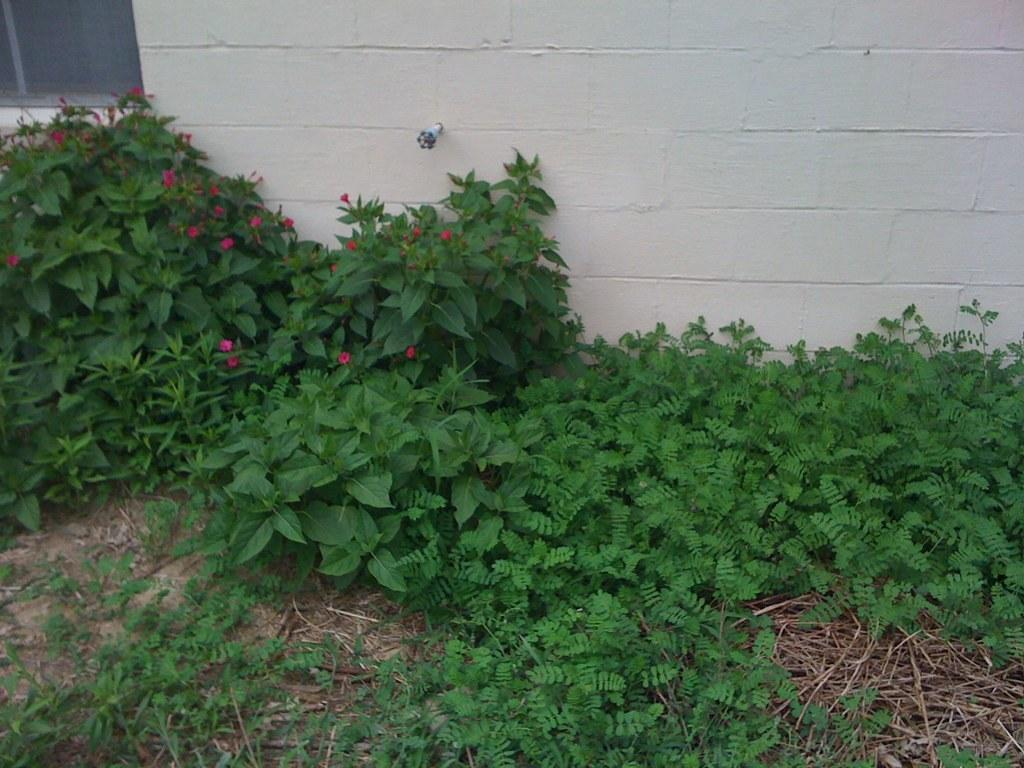What type of vegetation can be seen in the image? There are plants, shrubs, and flowers in the image. What other objects can be seen in the image? There are twigs visible in the image. What is visible in the background of the image? There is a wall in the background of the image. What type of vegetable is being harvested in the image? There is no vegetable being harvested in the image; it features plants, shrubs, twigs, and flowers. What emotion is being displayed by the clam in the image? There is no clam present in the image. 